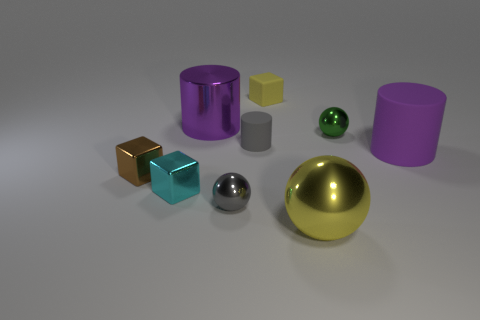Subtract all cubes. How many objects are left? 6 Subtract all large cyan matte spheres. Subtract all large yellow metal things. How many objects are left? 8 Add 9 tiny cyan blocks. How many tiny cyan blocks are left? 10 Add 1 tiny gray cylinders. How many tiny gray cylinders exist? 2 Subtract 0 brown cylinders. How many objects are left? 9 